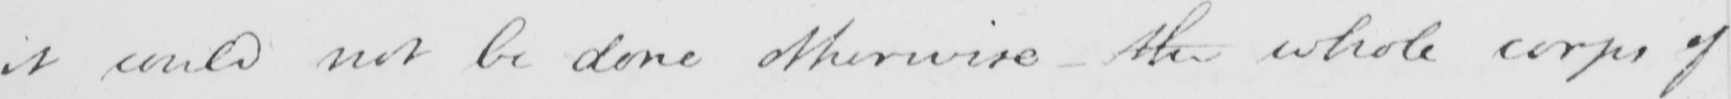Please transcribe the handwritten text in this image. it could not be done otherwise - the whole corps of 